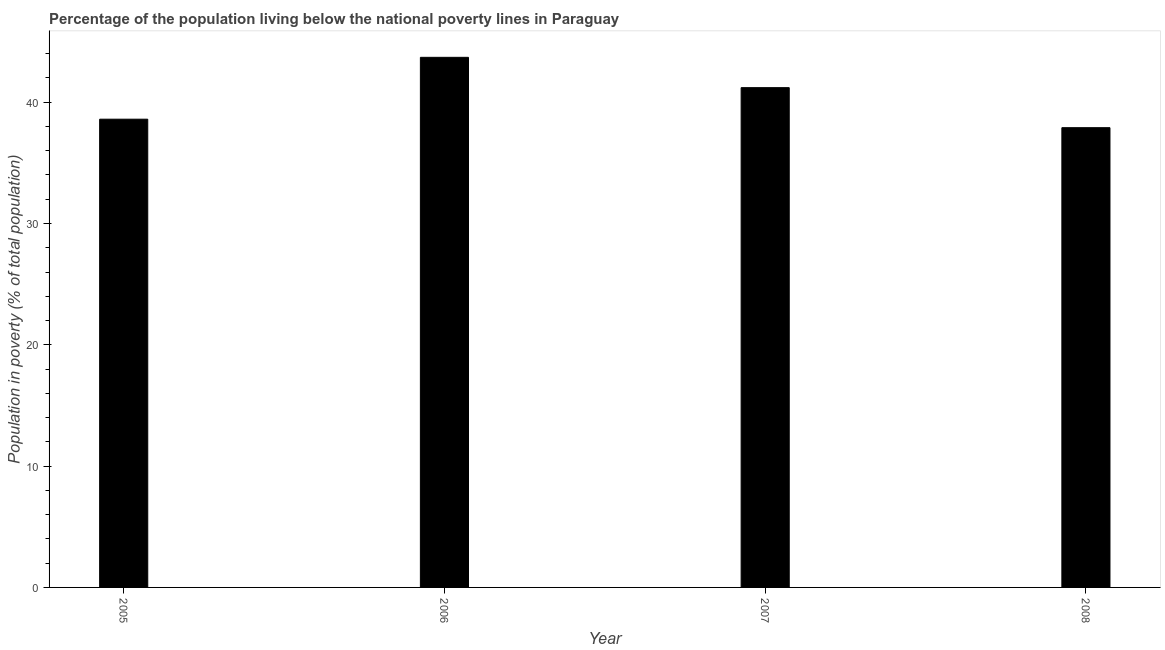Does the graph contain any zero values?
Keep it short and to the point. No. Does the graph contain grids?
Make the answer very short. No. What is the title of the graph?
Keep it short and to the point. Percentage of the population living below the national poverty lines in Paraguay. What is the label or title of the Y-axis?
Keep it short and to the point. Population in poverty (% of total population). What is the percentage of population living below poverty line in 2005?
Provide a short and direct response. 38.6. Across all years, what is the maximum percentage of population living below poverty line?
Your answer should be compact. 43.7. Across all years, what is the minimum percentage of population living below poverty line?
Keep it short and to the point. 37.9. In which year was the percentage of population living below poverty line maximum?
Keep it short and to the point. 2006. In which year was the percentage of population living below poverty line minimum?
Your response must be concise. 2008. What is the sum of the percentage of population living below poverty line?
Ensure brevity in your answer.  161.4. What is the average percentage of population living below poverty line per year?
Provide a short and direct response. 40.35. What is the median percentage of population living below poverty line?
Offer a terse response. 39.9. In how many years, is the percentage of population living below poverty line greater than 20 %?
Your answer should be very brief. 4. Do a majority of the years between 2006 and 2007 (inclusive) have percentage of population living below poverty line greater than 22 %?
Ensure brevity in your answer.  Yes. What is the ratio of the percentage of population living below poverty line in 2005 to that in 2006?
Your answer should be very brief. 0.88. Is the sum of the percentage of population living below poverty line in 2005 and 2008 greater than the maximum percentage of population living below poverty line across all years?
Offer a terse response. Yes. In how many years, is the percentage of population living below poverty line greater than the average percentage of population living below poverty line taken over all years?
Your answer should be very brief. 2. How many bars are there?
Your answer should be very brief. 4. Are all the bars in the graph horizontal?
Your answer should be compact. No. What is the difference between two consecutive major ticks on the Y-axis?
Offer a very short reply. 10. Are the values on the major ticks of Y-axis written in scientific E-notation?
Ensure brevity in your answer.  No. What is the Population in poverty (% of total population) of 2005?
Provide a succinct answer. 38.6. What is the Population in poverty (% of total population) of 2006?
Offer a very short reply. 43.7. What is the Population in poverty (% of total population) of 2007?
Provide a short and direct response. 41.2. What is the Population in poverty (% of total population) in 2008?
Ensure brevity in your answer.  37.9. What is the difference between the Population in poverty (% of total population) in 2005 and 2006?
Provide a short and direct response. -5.1. What is the difference between the Population in poverty (% of total population) in 2005 and 2007?
Make the answer very short. -2.6. What is the difference between the Population in poverty (% of total population) in 2006 and 2007?
Ensure brevity in your answer.  2.5. What is the ratio of the Population in poverty (% of total population) in 2005 to that in 2006?
Offer a terse response. 0.88. What is the ratio of the Population in poverty (% of total population) in 2005 to that in 2007?
Provide a short and direct response. 0.94. What is the ratio of the Population in poverty (% of total population) in 2006 to that in 2007?
Make the answer very short. 1.06. What is the ratio of the Population in poverty (% of total population) in 2006 to that in 2008?
Offer a very short reply. 1.15. What is the ratio of the Population in poverty (% of total population) in 2007 to that in 2008?
Provide a succinct answer. 1.09. 